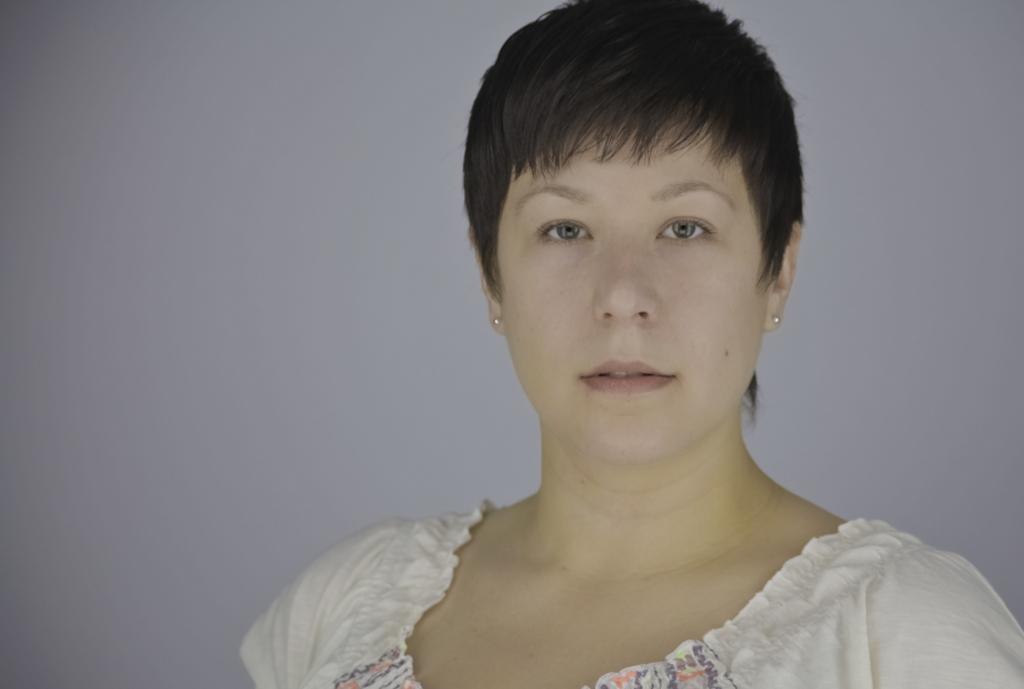Please provide a concise description of this image. In this image, we can see a woman wearing a white color dress. In the background, we can see a gray color. 